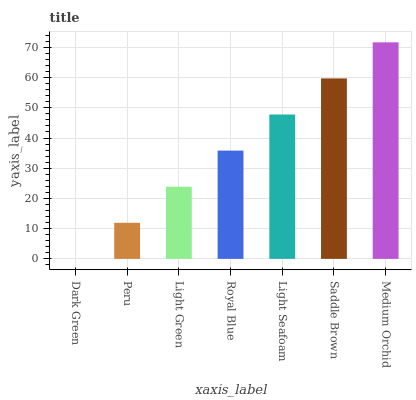Is Dark Green the minimum?
Answer yes or no. Yes. Is Medium Orchid the maximum?
Answer yes or no. Yes. Is Peru the minimum?
Answer yes or no. No. Is Peru the maximum?
Answer yes or no. No. Is Peru greater than Dark Green?
Answer yes or no. Yes. Is Dark Green less than Peru?
Answer yes or no. Yes. Is Dark Green greater than Peru?
Answer yes or no. No. Is Peru less than Dark Green?
Answer yes or no. No. Is Royal Blue the high median?
Answer yes or no. Yes. Is Royal Blue the low median?
Answer yes or no. Yes. Is Peru the high median?
Answer yes or no. No. Is Light Seafoam the low median?
Answer yes or no. No. 